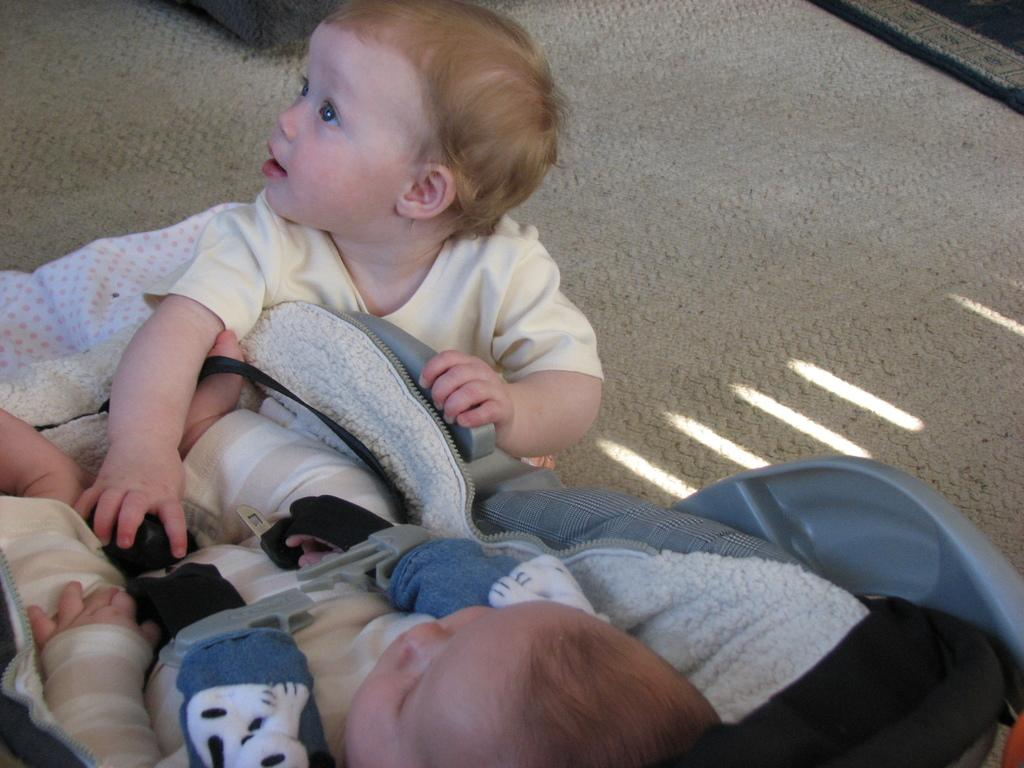What is the main subject of the image? There are two main subjects in the image, which are two babies. What are the babies wearing? Both babies are wearing cream-colored dresses. Where is the first baby located in the image? The first baby is laying on a baby bed. Where is the second baby located in the image? The second baby is sitting on the floor. What type of crow can be seen interacting with the babies in the image? There is no crow present in the image; it features two babies wearing cream-colored dresses. What wealth-related item is visible in the image? There is no wealth-related item visible in the image; it focuses on the babies and their clothing. 